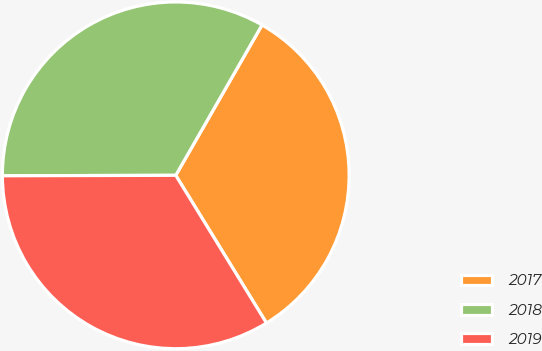<chart> <loc_0><loc_0><loc_500><loc_500><pie_chart><fcel>2017<fcel>2018<fcel>2019<nl><fcel>32.94%<fcel>33.33%<fcel>33.72%<nl></chart> 